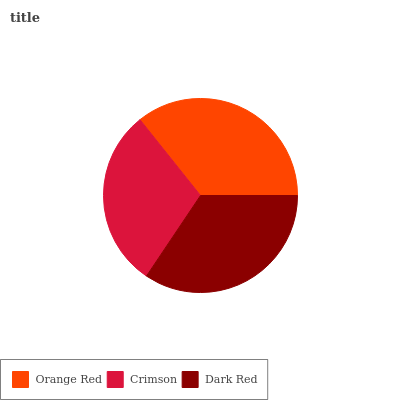Is Crimson the minimum?
Answer yes or no. Yes. Is Orange Red the maximum?
Answer yes or no. Yes. Is Dark Red the minimum?
Answer yes or no. No. Is Dark Red the maximum?
Answer yes or no. No. Is Dark Red greater than Crimson?
Answer yes or no. Yes. Is Crimson less than Dark Red?
Answer yes or no. Yes. Is Crimson greater than Dark Red?
Answer yes or no. No. Is Dark Red less than Crimson?
Answer yes or no. No. Is Dark Red the high median?
Answer yes or no. Yes. Is Dark Red the low median?
Answer yes or no. Yes. Is Crimson the high median?
Answer yes or no. No. Is Orange Red the low median?
Answer yes or no. No. 